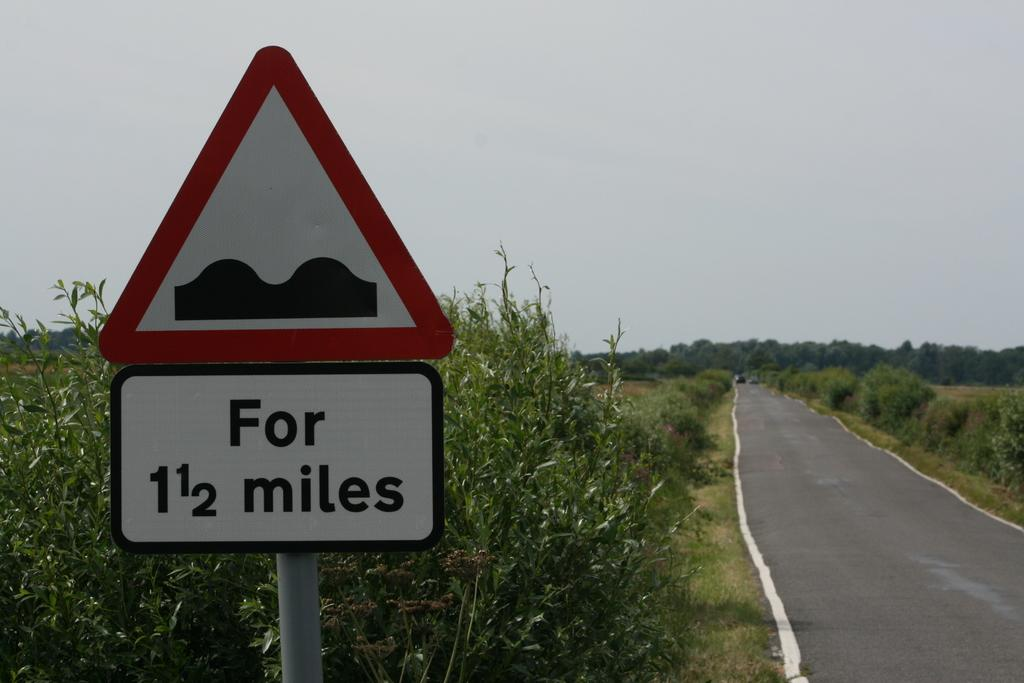Provide a one-sentence caption for the provided image. The road ahead is bumpy for the next mile and a half. 